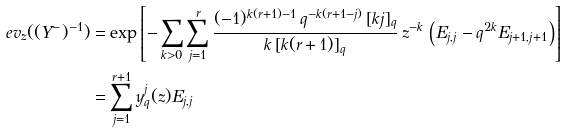Convert formula to latex. <formula><loc_0><loc_0><loc_500><loc_500>\ e v _ { z } ( ( Y ^ { - } ) ^ { - 1 } ) & = \exp \left [ - \sum _ { k > 0 } \sum _ { j = 1 } ^ { r } \frac { ( - 1 ) ^ { k ( r + 1 ) - 1 } \, q ^ { - k ( r + 1 - j ) } \, [ k j ] _ { q } } { k \, [ k ( r + 1 ) ] _ { q } } \, z ^ { - k } \, \left ( E _ { j , j } - q ^ { 2 k } E _ { j + 1 , j + 1 } \right ) \right ] \\ & = \sum _ { j = 1 } ^ { r + 1 } y _ { q } ^ { j } ( z ) E _ { j , j }</formula> 